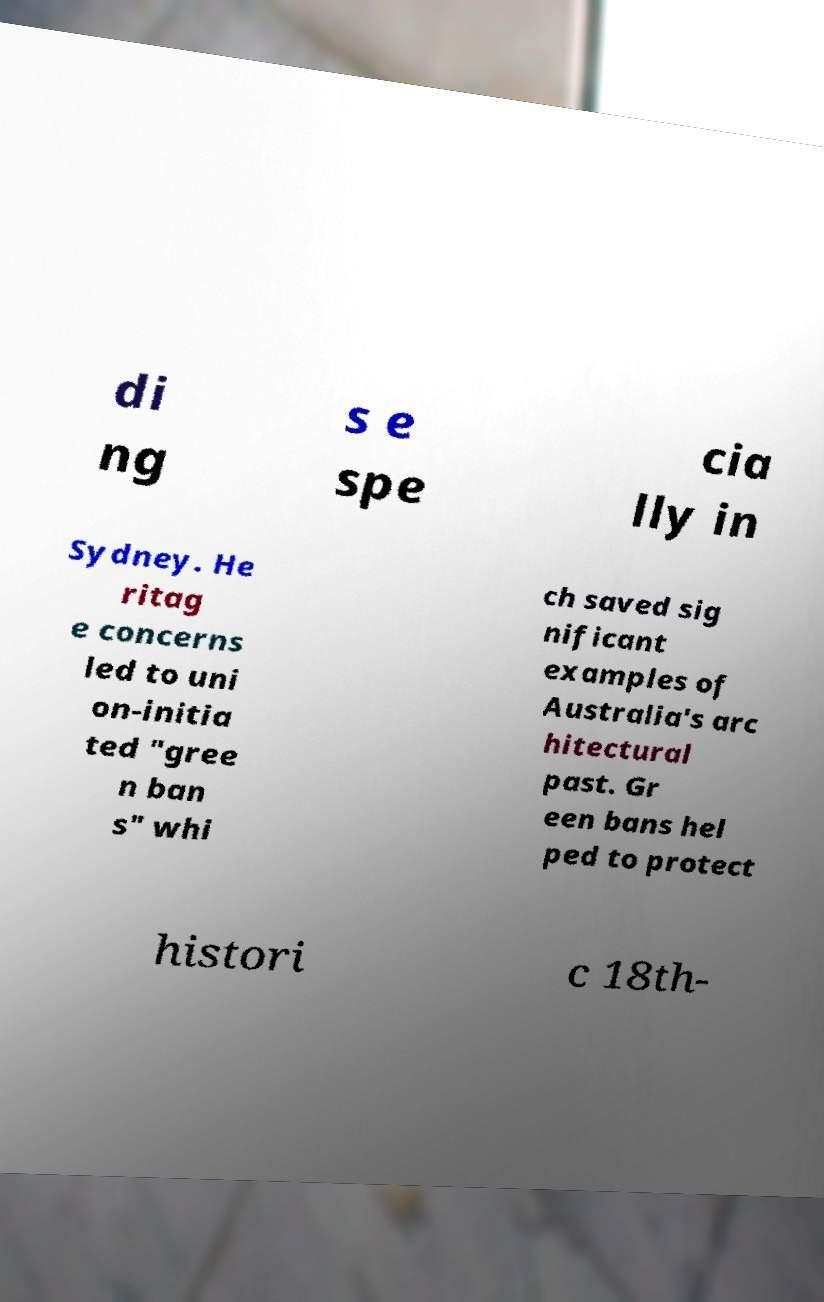There's text embedded in this image that I need extracted. Can you transcribe it verbatim? di ng s e spe cia lly in Sydney. He ritag e concerns led to uni on-initia ted "gree n ban s" whi ch saved sig nificant examples of Australia's arc hitectural past. Gr een bans hel ped to protect histori c 18th- 